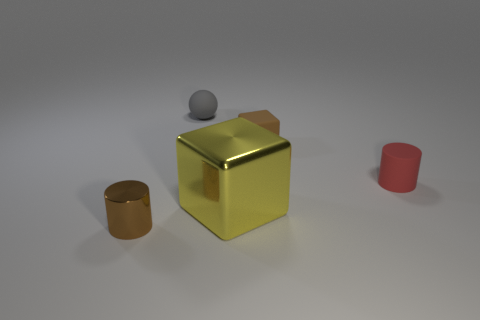Is the number of metal cylinders to the right of the small brown matte object the same as the number of large yellow cylinders?
Give a very brief answer. Yes. Is there any other thing that is the same size as the brown shiny cylinder?
Ensure brevity in your answer.  Yes. There is a metallic object that is the same shape as the red rubber thing; what color is it?
Offer a very short reply. Brown. How many other large objects have the same shape as the yellow object?
Your answer should be compact. 0. What is the material of the small cylinder that is the same color as the tiny rubber cube?
Offer a very short reply. Metal. What number of small brown rubber things are there?
Offer a terse response. 1. Are there any cylinders that have the same material as the large yellow thing?
Provide a short and direct response. Yes. There is a thing that is the same color as the tiny matte cube; what is its size?
Your answer should be compact. Small. Does the cylinder that is left of the gray rubber ball have the same size as the cube in front of the tiny red object?
Offer a terse response. No. What size is the brown object that is behind the large metallic object?
Give a very brief answer. Small. 